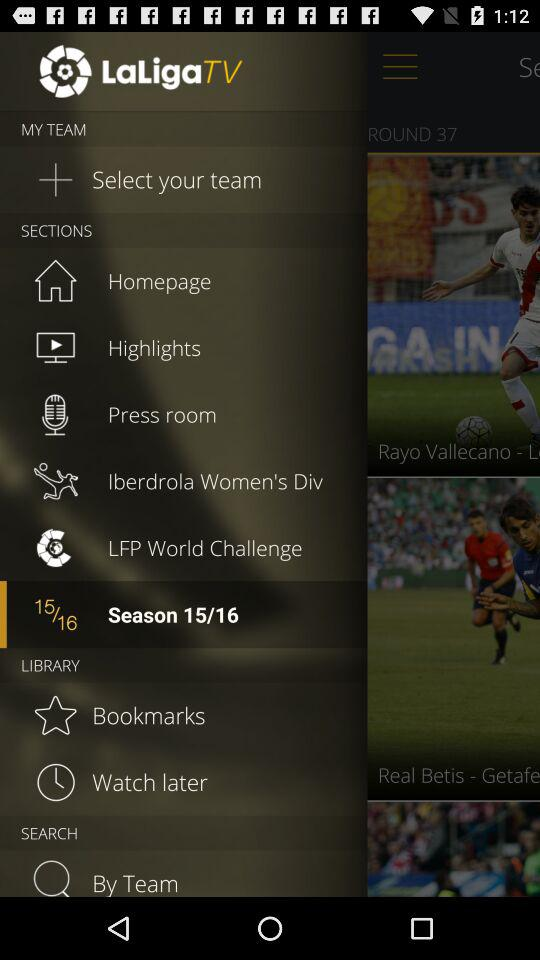What is the app name? The app name is "LaLiga TV". 